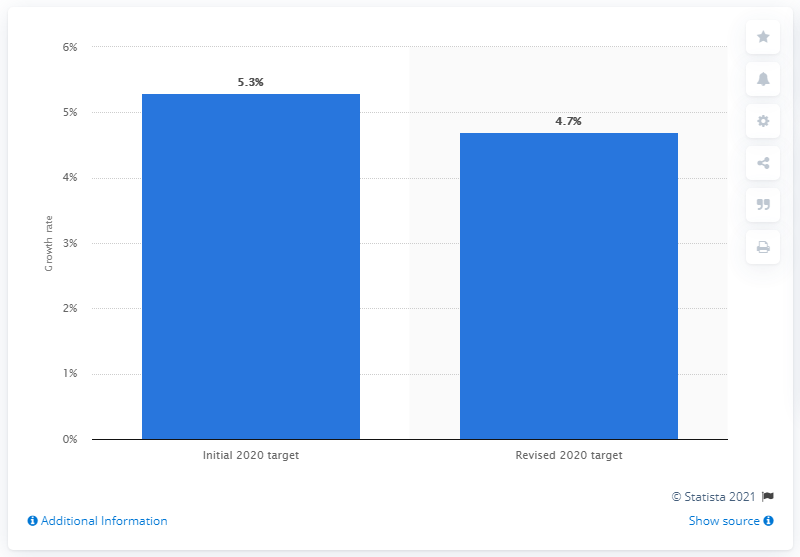Specify some key components in this picture. The outlook for Indonesia's GDP growth in March 2020 was 4.7%. 